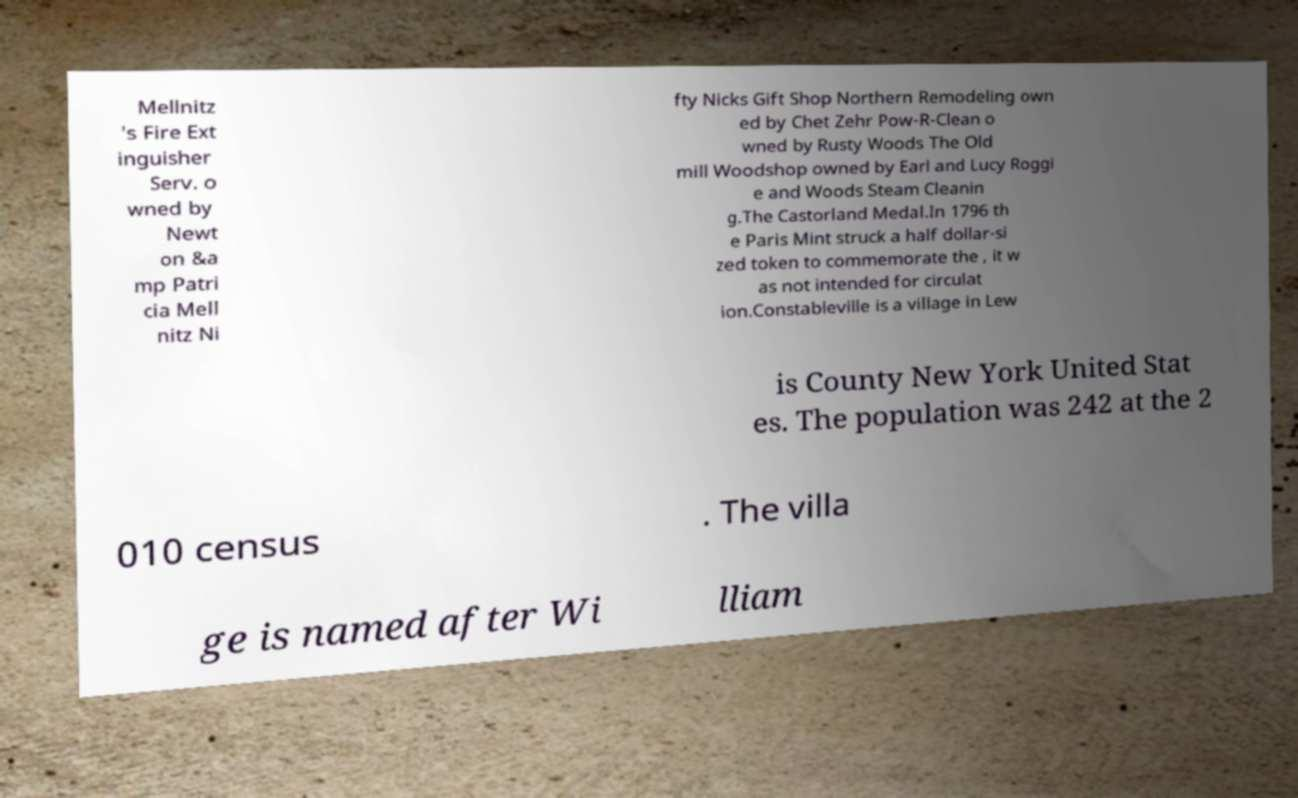What messages or text are displayed in this image? I need them in a readable, typed format. Mellnitz 's Fire Ext inguisher Serv. o wned by Newt on &a mp Patri cia Mell nitz Ni fty Nicks Gift Shop Northern Remodeling own ed by Chet Zehr Pow-R-Clean o wned by Rusty Woods The Old mill Woodshop owned by Earl and Lucy Roggi e and Woods Steam Cleanin g.The Castorland Medal.In 1796 th e Paris Mint struck a half dollar-si zed token to commemorate the , it w as not intended for circulat ion.Constableville is a village in Lew is County New York United Stat es. The population was 242 at the 2 010 census . The villa ge is named after Wi lliam 